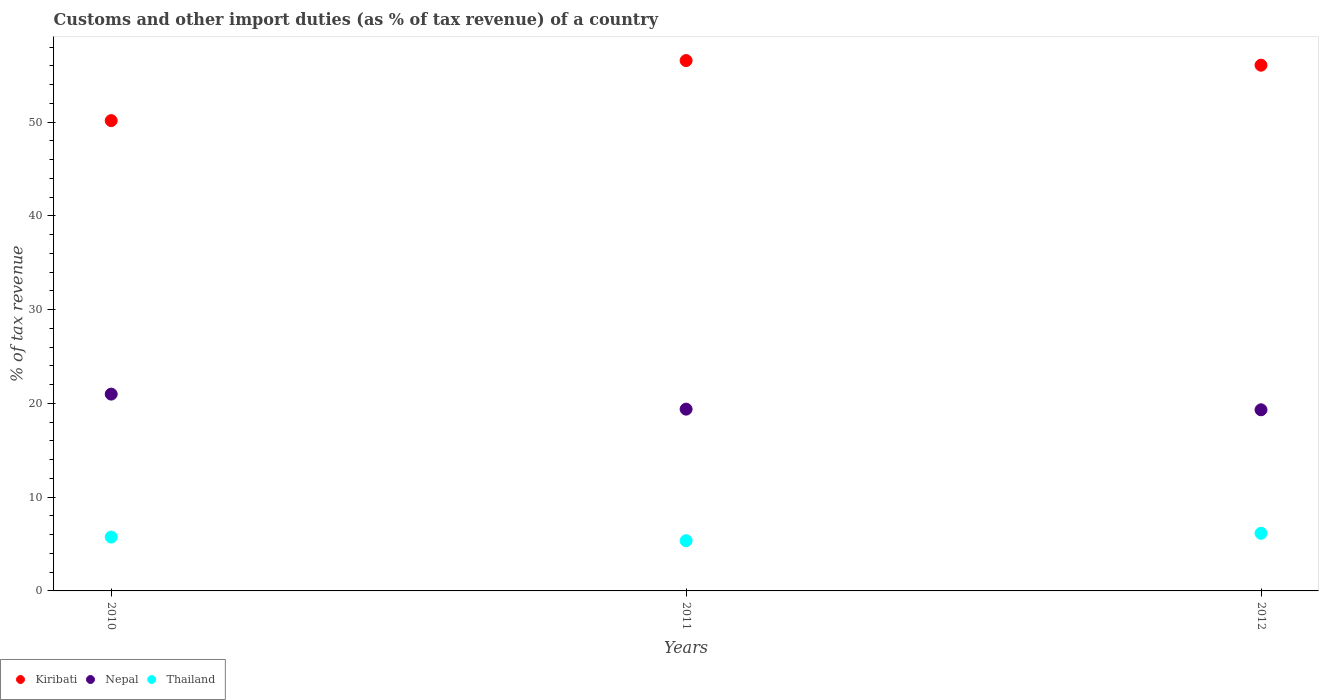How many different coloured dotlines are there?
Keep it short and to the point. 3. Is the number of dotlines equal to the number of legend labels?
Offer a very short reply. Yes. What is the percentage of tax revenue from customs in Nepal in 2011?
Your answer should be compact. 19.39. Across all years, what is the maximum percentage of tax revenue from customs in Kiribati?
Keep it short and to the point. 56.57. Across all years, what is the minimum percentage of tax revenue from customs in Nepal?
Give a very brief answer. 19.32. In which year was the percentage of tax revenue from customs in Kiribati minimum?
Your response must be concise. 2010. What is the total percentage of tax revenue from customs in Thailand in the graph?
Provide a succinct answer. 17.25. What is the difference between the percentage of tax revenue from customs in Thailand in 2011 and that in 2012?
Your response must be concise. -0.79. What is the difference between the percentage of tax revenue from customs in Nepal in 2010 and the percentage of tax revenue from customs in Thailand in 2012?
Make the answer very short. 14.85. What is the average percentage of tax revenue from customs in Kiribati per year?
Give a very brief answer. 54.27. In the year 2010, what is the difference between the percentage of tax revenue from customs in Kiribati and percentage of tax revenue from customs in Thailand?
Make the answer very short. 44.42. What is the ratio of the percentage of tax revenue from customs in Thailand in 2010 to that in 2011?
Your answer should be very brief. 1.07. Is the percentage of tax revenue from customs in Thailand in 2010 less than that in 2012?
Your answer should be very brief. Yes. Is the difference between the percentage of tax revenue from customs in Kiribati in 2010 and 2012 greater than the difference between the percentage of tax revenue from customs in Thailand in 2010 and 2012?
Your answer should be very brief. No. What is the difference between the highest and the second highest percentage of tax revenue from customs in Nepal?
Offer a very short reply. 1.6. What is the difference between the highest and the lowest percentage of tax revenue from customs in Kiribati?
Make the answer very short. 6.4. Is it the case that in every year, the sum of the percentage of tax revenue from customs in Kiribati and percentage of tax revenue from customs in Nepal  is greater than the percentage of tax revenue from customs in Thailand?
Make the answer very short. Yes. Does the percentage of tax revenue from customs in Thailand monotonically increase over the years?
Offer a very short reply. No. Is the percentage of tax revenue from customs in Thailand strictly less than the percentage of tax revenue from customs in Nepal over the years?
Provide a short and direct response. Yes. How many dotlines are there?
Make the answer very short. 3. How many years are there in the graph?
Offer a terse response. 3. Are the values on the major ticks of Y-axis written in scientific E-notation?
Give a very brief answer. No. Where does the legend appear in the graph?
Your answer should be very brief. Bottom left. How many legend labels are there?
Make the answer very short. 3. What is the title of the graph?
Give a very brief answer. Customs and other import duties (as % of tax revenue) of a country. Does "Ghana" appear as one of the legend labels in the graph?
Provide a succinct answer. No. What is the label or title of the X-axis?
Your response must be concise. Years. What is the label or title of the Y-axis?
Give a very brief answer. % of tax revenue. What is the % of tax revenue of Kiribati in 2010?
Give a very brief answer. 50.17. What is the % of tax revenue of Nepal in 2010?
Keep it short and to the point. 20.99. What is the % of tax revenue in Thailand in 2010?
Offer a terse response. 5.74. What is the % of tax revenue of Kiribati in 2011?
Ensure brevity in your answer.  56.57. What is the % of tax revenue of Nepal in 2011?
Your answer should be very brief. 19.39. What is the % of tax revenue in Thailand in 2011?
Your answer should be very brief. 5.36. What is the % of tax revenue in Kiribati in 2012?
Ensure brevity in your answer.  56.08. What is the % of tax revenue of Nepal in 2012?
Offer a terse response. 19.32. What is the % of tax revenue of Thailand in 2012?
Provide a succinct answer. 6.15. Across all years, what is the maximum % of tax revenue in Kiribati?
Your answer should be compact. 56.57. Across all years, what is the maximum % of tax revenue of Nepal?
Provide a succinct answer. 20.99. Across all years, what is the maximum % of tax revenue of Thailand?
Give a very brief answer. 6.15. Across all years, what is the minimum % of tax revenue of Kiribati?
Keep it short and to the point. 50.17. Across all years, what is the minimum % of tax revenue of Nepal?
Your response must be concise. 19.32. Across all years, what is the minimum % of tax revenue of Thailand?
Keep it short and to the point. 5.36. What is the total % of tax revenue in Kiribati in the graph?
Offer a terse response. 162.81. What is the total % of tax revenue of Nepal in the graph?
Ensure brevity in your answer.  59.7. What is the total % of tax revenue of Thailand in the graph?
Your answer should be compact. 17.25. What is the difference between the % of tax revenue in Kiribati in 2010 and that in 2011?
Offer a terse response. -6.4. What is the difference between the % of tax revenue in Nepal in 2010 and that in 2011?
Your answer should be very brief. 1.6. What is the difference between the % of tax revenue of Thailand in 2010 and that in 2011?
Your answer should be compact. 0.38. What is the difference between the % of tax revenue in Kiribati in 2010 and that in 2012?
Provide a succinct answer. -5.91. What is the difference between the % of tax revenue of Nepal in 2010 and that in 2012?
Provide a short and direct response. 1.67. What is the difference between the % of tax revenue of Thailand in 2010 and that in 2012?
Make the answer very short. -0.4. What is the difference between the % of tax revenue of Kiribati in 2011 and that in 2012?
Provide a short and direct response. 0.49. What is the difference between the % of tax revenue of Nepal in 2011 and that in 2012?
Give a very brief answer. 0.07. What is the difference between the % of tax revenue of Thailand in 2011 and that in 2012?
Your answer should be compact. -0.79. What is the difference between the % of tax revenue of Kiribati in 2010 and the % of tax revenue of Nepal in 2011?
Your response must be concise. 30.78. What is the difference between the % of tax revenue of Kiribati in 2010 and the % of tax revenue of Thailand in 2011?
Keep it short and to the point. 44.81. What is the difference between the % of tax revenue in Nepal in 2010 and the % of tax revenue in Thailand in 2011?
Provide a succinct answer. 15.64. What is the difference between the % of tax revenue in Kiribati in 2010 and the % of tax revenue in Nepal in 2012?
Provide a succinct answer. 30.84. What is the difference between the % of tax revenue of Kiribati in 2010 and the % of tax revenue of Thailand in 2012?
Give a very brief answer. 44.02. What is the difference between the % of tax revenue of Nepal in 2010 and the % of tax revenue of Thailand in 2012?
Your answer should be compact. 14.85. What is the difference between the % of tax revenue of Kiribati in 2011 and the % of tax revenue of Nepal in 2012?
Give a very brief answer. 37.25. What is the difference between the % of tax revenue in Kiribati in 2011 and the % of tax revenue in Thailand in 2012?
Your answer should be compact. 50.42. What is the difference between the % of tax revenue in Nepal in 2011 and the % of tax revenue in Thailand in 2012?
Ensure brevity in your answer.  13.24. What is the average % of tax revenue of Kiribati per year?
Ensure brevity in your answer.  54.27. What is the average % of tax revenue of Nepal per year?
Ensure brevity in your answer.  19.9. What is the average % of tax revenue in Thailand per year?
Provide a succinct answer. 5.75. In the year 2010, what is the difference between the % of tax revenue of Kiribati and % of tax revenue of Nepal?
Make the answer very short. 29.17. In the year 2010, what is the difference between the % of tax revenue in Kiribati and % of tax revenue in Thailand?
Your answer should be very brief. 44.42. In the year 2010, what is the difference between the % of tax revenue of Nepal and % of tax revenue of Thailand?
Your response must be concise. 15.25. In the year 2011, what is the difference between the % of tax revenue in Kiribati and % of tax revenue in Nepal?
Offer a terse response. 37.18. In the year 2011, what is the difference between the % of tax revenue of Kiribati and % of tax revenue of Thailand?
Ensure brevity in your answer.  51.21. In the year 2011, what is the difference between the % of tax revenue in Nepal and % of tax revenue in Thailand?
Ensure brevity in your answer.  14.03. In the year 2012, what is the difference between the % of tax revenue in Kiribati and % of tax revenue in Nepal?
Provide a short and direct response. 36.76. In the year 2012, what is the difference between the % of tax revenue in Kiribati and % of tax revenue in Thailand?
Offer a very short reply. 49.93. In the year 2012, what is the difference between the % of tax revenue in Nepal and % of tax revenue in Thailand?
Provide a short and direct response. 13.17. What is the ratio of the % of tax revenue in Kiribati in 2010 to that in 2011?
Ensure brevity in your answer.  0.89. What is the ratio of the % of tax revenue in Nepal in 2010 to that in 2011?
Your answer should be compact. 1.08. What is the ratio of the % of tax revenue of Thailand in 2010 to that in 2011?
Your response must be concise. 1.07. What is the ratio of the % of tax revenue in Kiribati in 2010 to that in 2012?
Your answer should be very brief. 0.89. What is the ratio of the % of tax revenue in Nepal in 2010 to that in 2012?
Offer a terse response. 1.09. What is the ratio of the % of tax revenue in Thailand in 2010 to that in 2012?
Ensure brevity in your answer.  0.93. What is the ratio of the % of tax revenue of Kiribati in 2011 to that in 2012?
Your answer should be compact. 1.01. What is the ratio of the % of tax revenue of Nepal in 2011 to that in 2012?
Offer a very short reply. 1. What is the ratio of the % of tax revenue of Thailand in 2011 to that in 2012?
Offer a very short reply. 0.87. What is the difference between the highest and the second highest % of tax revenue of Kiribati?
Offer a terse response. 0.49. What is the difference between the highest and the second highest % of tax revenue of Nepal?
Provide a short and direct response. 1.6. What is the difference between the highest and the second highest % of tax revenue in Thailand?
Keep it short and to the point. 0.4. What is the difference between the highest and the lowest % of tax revenue of Kiribati?
Offer a terse response. 6.4. What is the difference between the highest and the lowest % of tax revenue in Nepal?
Give a very brief answer. 1.67. What is the difference between the highest and the lowest % of tax revenue of Thailand?
Your answer should be compact. 0.79. 